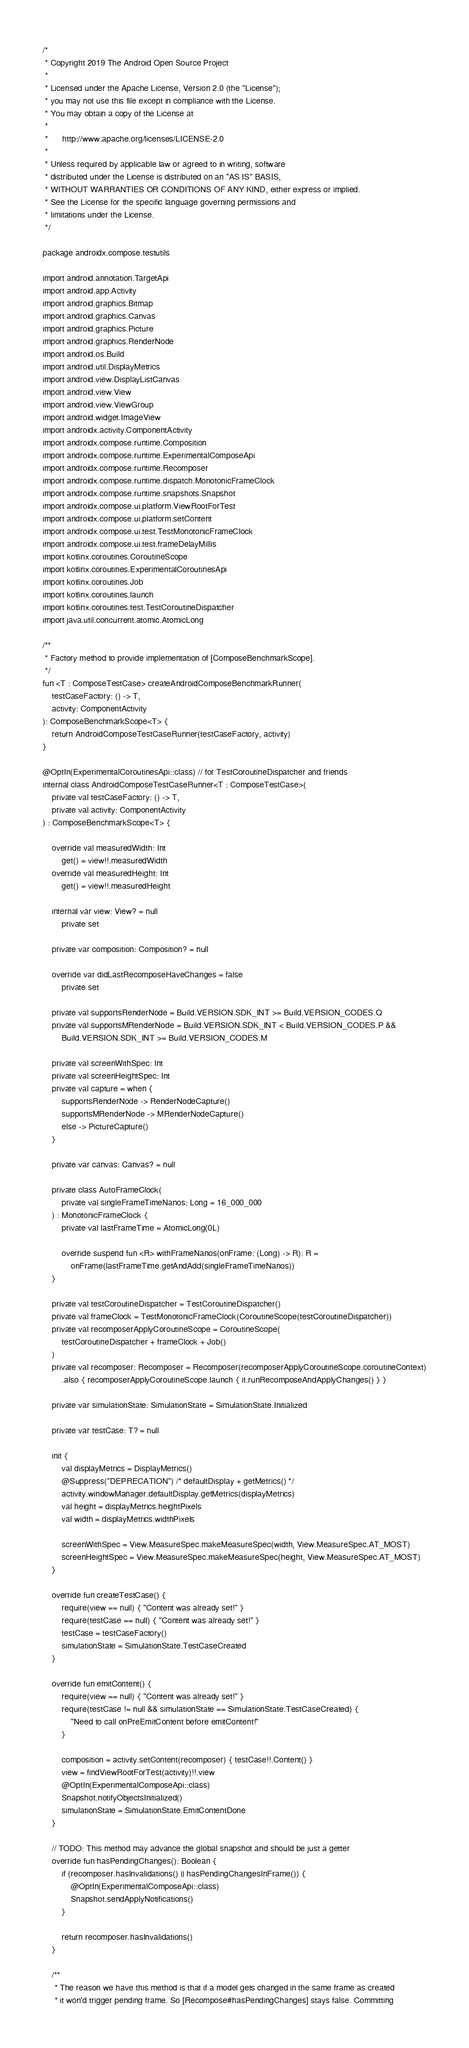<code> <loc_0><loc_0><loc_500><loc_500><_Kotlin_>/*
 * Copyright 2019 The Android Open Source Project
 *
 * Licensed under the Apache License, Version 2.0 (the "License");
 * you may not use this file except in compliance with the License.
 * You may obtain a copy of the License at
 *
 *      http://www.apache.org/licenses/LICENSE-2.0
 *
 * Unless required by applicable law or agreed to in writing, software
 * distributed under the License is distributed on an "AS IS" BASIS,
 * WITHOUT WARRANTIES OR CONDITIONS OF ANY KIND, either express or implied.
 * See the License for the specific language governing permissions and
 * limitations under the License.
 */

package androidx.compose.testutils

import android.annotation.TargetApi
import android.app.Activity
import android.graphics.Bitmap
import android.graphics.Canvas
import android.graphics.Picture
import android.graphics.RenderNode
import android.os.Build
import android.util.DisplayMetrics
import android.view.DisplayListCanvas
import android.view.View
import android.view.ViewGroup
import android.widget.ImageView
import androidx.activity.ComponentActivity
import androidx.compose.runtime.Composition
import androidx.compose.runtime.ExperimentalComposeApi
import androidx.compose.runtime.Recomposer
import androidx.compose.runtime.dispatch.MonotonicFrameClock
import androidx.compose.runtime.snapshots.Snapshot
import androidx.compose.ui.platform.ViewRootForTest
import androidx.compose.ui.platform.setContent
import androidx.compose.ui.test.TestMonotonicFrameClock
import androidx.compose.ui.test.frameDelayMillis
import kotlinx.coroutines.CoroutineScope
import kotlinx.coroutines.ExperimentalCoroutinesApi
import kotlinx.coroutines.Job
import kotlinx.coroutines.launch
import kotlinx.coroutines.test.TestCoroutineDispatcher
import java.util.concurrent.atomic.AtomicLong

/**
 * Factory method to provide implementation of [ComposeBenchmarkScope].
 */
fun <T : ComposeTestCase> createAndroidComposeBenchmarkRunner(
    testCaseFactory: () -> T,
    activity: ComponentActivity
): ComposeBenchmarkScope<T> {
    return AndroidComposeTestCaseRunner(testCaseFactory, activity)
}

@OptIn(ExperimentalCoroutinesApi::class) // for TestCoroutineDispatcher and friends
internal class AndroidComposeTestCaseRunner<T : ComposeTestCase>(
    private val testCaseFactory: () -> T,
    private val activity: ComponentActivity
) : ComposeBenchmarkScope<T> {

    override val measuredWidth: Int
        get() = view!!.measuredWidth
    override val measuredHeight: Int
        get() = view!!.measuredHeight

    internal var view: View? = null
        private set

    private var composition: Composition? = null

    override var didLastRecomposeHaveChanges = false
        private set

    private val supportsRenderNode = Build.VERSION.SDK_INT >= Build.VERSION_CODES.Q
    private val supportsMRenderNode = Build.VERSION.SDK_INT < Build.VERSION_CODES.P &&
        Build.VERSION.SDK_INT >= Build.VERSION_CODES.M

    private val screenWithSpec: Int
    private val screenHeightSpec: Int
    private val capture = when {
        supportsRenderNode -> RenderNodeCapture()
        supportsMRenderNode -> MRenderNodeCapture()
        else -> PictureCapture()
    }

    private var canvas: Canvas? = null

    private class AutoFrameClock(
        private val singleFrameTimeNanos: Long = 16_000_000
    ) : MonotonicFrameClock {
        private val lastFrameTime = AtomicLong(0L)

        override suspend fun <R> withFrameNanos(onFrame: (Long) -> R): R =
            onFrame(lastFrameTime.getAndAdd(singleFrameTimeNanos))
    }

    private val testCoroutineDispatcher = TestCoroutineDispatcher()
    private val frameClock = TestMonotonicFrameClock(CoroutineScope(testCoroutineDispatcher))
    private val recomposerApplyCoroutineScope = CoroutineScope(
        testCoroutineDispatcher + frameClock + Job()
    )
    private val recomposer: Recomposer = Recomposer(recomposerApplyCoroutineScope.coroutineContext)
        .also { recomposerApplyCoroutineScope.launch { it.runRecomposeAndApplyChanges() } }

    private var simulationState: SimulationState = SimulationState.Initialized

    private var testCase: T? = null

    init {
        val displayMetrics = DisplayMetrics()
        @Suppress("DEPRECATION") /* defaultDisplay + getMetrics() */
        activity.windowManager.defaultDisplay.getMetrics(displayMetrics)
        val height = displayMetrics.heightPixels
        val width = displayMetrics.widthPixels

        screenWithSpec = View.MeasureSpec.makeMeasureSpec(width, View.MeasureSpec.AT_MOST)
        screenHeightSpec = View.MeasureSpec.makeMeasureSpec(height, View.MeasureSpec.AT_MOST)
    }

    override fun createTestCase() {
        require(view == null) { "Content was already set!" }
        require(testCase == null) { "Content was already set!" }
        testCase = testCaseFactory()
        simulationState = SimulationState.TestCaseCreated
    }

    override fun emitContent() {
        require(view == null) { "Content was already set!" }
        require(testCase != null && simulationState == SimulationState.TestCaseCreated) {
            "Need to call onPreEmitContent before emitContent!"
        }

        composition = activity.setContent(recomposer) { testCase!!.Content() }
        view = findViewRootForTest(activity)!!.view
        @OptIn(ExperimentalComposeApi::class)
        Snapshot.notifyObjectsInitialized()
        simulationState = SimulationState.EmitContentDone
    }

    // TODO: This method may advance the global snapshot and should be just a getter
    override fun hasPendingChanges(): Boolean {
        if (recomposer.hasInvalidations() || hasPendingChangesInFrame()) {
            @OptIn(ExperimentalComposeApi::class)
            Snapshot.sendApplyNotifications()
        }

        return recomposer.hasInvalidations()
    }

    /**
     * The reason we have this method is that if a model gets changed in the same frame as created
     * it won'd trigger pending frame. So [Recompose#hasPendingChanges] stays false. Committing</code> 